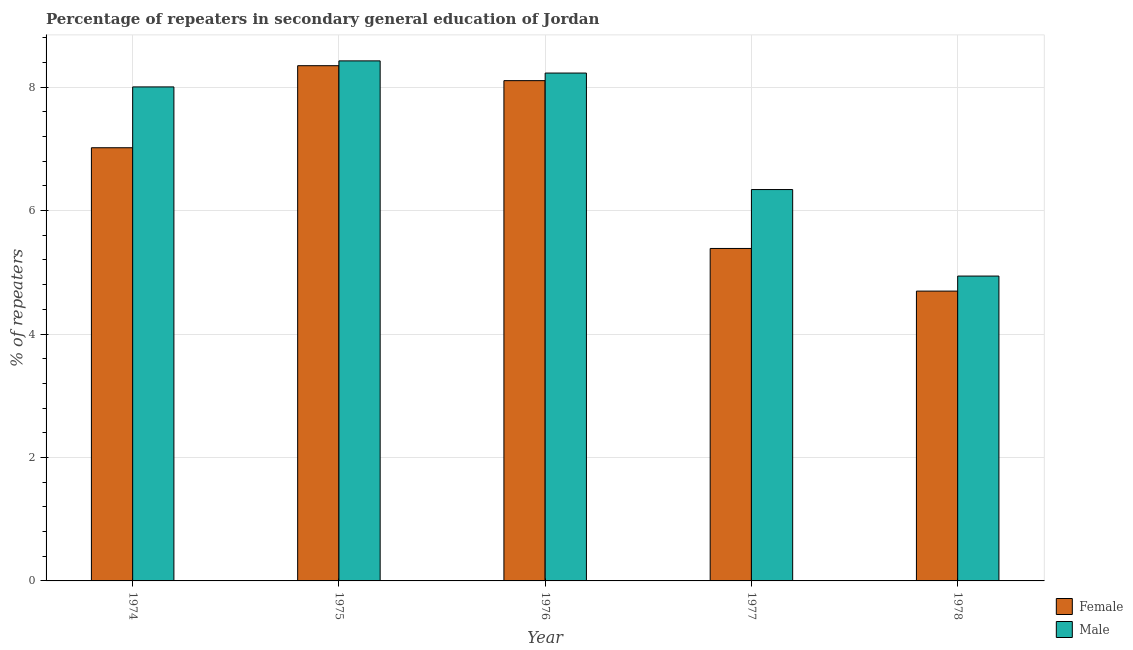How many different coloured bars are there?
Make the answer very short. 2. How many groups of bars are there?
Your answer should be very brief. 5. Are the number of bars per tick equal to the number of legend labels?
Offer a very short reply. Yes. How many bars are there on the 5th tick from the left?
Your answer should be very brief. 2. How many bars are there on the 4th tick from the right?
Give a very brief answer. 2. What is the label of the 1st group of bars from the left?
Your answer should be compact. 1974. In how many cases, is the number of bars for a given year not equal to the number of legend labels?
Your answer should be compact. 0. What is the percentage of female repeaters in 1978?
Your answer should be compact. 4.7. Across all years, what is the maximum percentage of male repeaters?
Your answer should be very brief. 8.43. Across all years, what is the minimum percentage of female repeaters?
Your answer should be very brief. 4.7. In which year was the percentage of female repeaters maximum?
Your answer should be very brief. 1975. In which year was the percentage of female repeaters minimum?
Make the answer very short. 1978. What is the total percentage of female repeaters in the graph?
Offer a terse response. 33.56. What is the difference between the percentage of female repeaters in 1975 and that in 1977?
Your answer should be very brief. 2.96. What is the difference between the percentage of male repeaters in 1976 and the percentage of female repeaters in 1977?
Offer a terse response. 1.89. What is the average percentage of female repeaters per year?
Make the answer very short. 6.71. In the year 1977, what is the difference between the percentage of female repeaters and percentage of male repeaters?
Your response must be concise. 0. What is the ratio of the percentage of female repeaters in 1975 to that in 1976?
Keep it short and to the point. 1.03. Is the percentage of male repeaters in 1974 less than that in 1976?
Keep it short and to the point. Yes. What is the difference between the highest and the second highest percentage of male repeaters?
Your response must be concise. 0.2. What is the difference between the highest and the lowest percentage of female repeaters?
Make the answer very short. 3.65. How many bars are there?
Ensure brevity in your answer.  10. Are all the bars in the graph horizontal?
Ensure brevity in your answer.  No. What is the difference between two consecutive major ticks on the Y-axis?
Your response must be concise. 2. Are the values on the major ticks of Y-axis written in scientific E-notation?
Offer a very short reply. No. Does the graph contain grids?
Provide a succinct answer. Yes. Where does the legend appear in the graph?
Your answer should be very brief. Bottom right. How are the legend labels stacked?
Offer a very short reply. Vertical. What is the title of the graph?
Your answer should be very brief. Percentage of repeaters in secondary general education of Jordan. Does "Arms exports" appear as one of the legend labels in the graph?
Your answer should be compact. No. What is the label or title of the Y-axis?
Make the answer very short. % of repeaters. What is the % of repeaters of Female in 1974?
Offer a terse response. 7.02. What is the % of repeaters of Male in 1974?
Give a very brief answer. 8. What is the % of repeaters of Female in 1975?
Your answer should be very brief. 8.35. What is the % of repeaters of Male in 1975?
Give a very brief answer. 8.43. What is the % of repeaters in Female in 1976?
Your answer should be compact. 8.11. What is the % of repeaters in Male in 1976?
Your answer should be very brief. 8.23. What is the % of repeaters in Female in 1977?
Provide a short and direct response. 5.39. What is the % of repeaters in Male in 1977?
Provide a succinct answer. 6.34. What is the % of repeaters in Female in 1978?
Ensure brevity in your answer.  4.7. What is the % of repeaters in Male in 1978?
Your answer should be very brief. 4.94. Across all years, what is the maximum % of repeaters in Female?
Ensure brevity in your answer.  8.35. Across all years, what is the maximum % of repeaters in Male?
Your answer should be very brief. 8.43. Across all years, what is the minimum % of repeaters in Female?
Your response must be concise. 4.7. Across all years, what is the minimum % of repeaters in Male?
Provide a short and direct response. 4.94. What is the total % of repeaters of Female in the graph?
Give a very brief answer. 33.56. What is the total % of repeaters of Male in the graph?
Provide a short and direct response. 35.94. What is the difference between the % of repeaters of Female in 1974 and that in 1975?
Your answer should be compact. -1.33. What is the difference between the % of repeaters of Male in 1974 and that in 1975?
Offer a terse response. -0.42. What is the difference between the % of repeaters of Female in 1974 and that in 1976?
Give a very brief answer. -1.09. What is the difference between the % of repeaters in Male in 1974 and that in 1976?
Give a very brief answer. -0.22. What is the difference between the % of repeaters of Female in 1974 and that in 1977?
Offer a very short reply. 1.63. What is the difference between the % of repeaters in Male in 1974 and that in 1977?
Ensure brevity in your answer.  1.66. What is the difference between the % of repeaters of Female in 1974 and that in 1978?
Make the answer very short. 2.32. What is the difference between the % of repeaters of Male in 1974 and that in 1978?
Offer a terse response. 3.07. What is the difference between the % of repeaters in Female in 1975 and that in 1976?
Your response must be concise. 0.24. What is the difference between the % of repeaters in Male in 1975 and that in 1976?
Your answer should be compact. 0.2. What is the difference between the % of repeaters of Female in 1975 and that in 1977?
Ensure brevity in your answer.  2.96. What is the difference between the % of repeaters in Male in 1975 and that in 1977?
Your answer should be compact. 2.08. What is the difference between the % of repeaters of Female in 1975 and that in 1978?
Keep it short and to the point. 3.65. What is the difference between the % of repeaters in Male in 1975 and that in 1978?
Make the answer very short. 3.49. What is the difference between the % of repeaters in Female in 1976 and that in 1977?
Offer a very short reply. 2.72. What is the difference between the % of repeaters in Male in 1976 and that in 1977?
Keep it short and to the point. 1.89. What is the difference between the % of repeaters of Female in 1976 and that in 1978?
Your answer should be very brief. 3.41. What is the difference between the % of repeaters of Male in 1976 and that in 1978?
Give a very brief answer. 3.29. What is the difference between the % of repeaters of Female in 1977 and that in 1978?
Make the answer very short. 0.69. What is the difference between the % of repeaters of Male in 1977 and that in 1978?
Offer a very short reply. 1.4. What is the difference between the % of repeaters in Female in 1974 and the % of repeaters in Male in 1975?
Offer a very short reply. -1.41. What is the difference between the % of repeaters of Female in 1974 and the % of repeaters of Male in 1976?
Ensure brevity in your answer.  -1.21. What is the difference between the % of repeaters of Female in 1974 and the % of repeaters of Male in 1977?
Offer a very short reply. 0.68. What is the difference between the % of repeaters in Female in 1974 and the % of repeaters in Male in 1978?
Your answer should be very brief. 2.08. What is the difference between the % of repeaters of Female in 1975 and the % of repeaters of Male in 1976?
Give a very brief answer. 0.12. What is the difference between the % of repeaters in Female in 1975 and the % of repeaters in Male in 1977?
Offer a very short reply. 2.01. What is the difference between the % of repeaters in Female in 1975 and the % of repeaters in Male in 1978?
Make the answer very short. 3.41. What is the difference between the % of repeaters of Female in 1976 and the % of repeaters of Male in 1977?
Your response must be concise. 1.76. What is the difference between the % of repeaters of Female in 1976 and the % of repeaters of Male in 1978?
Keep it short and to the point. 3.17. What is the difference between the % of repeaters in Female in 1977 and the % of repeaters in Male in 1978?
Your answer should be very brief. 0.45. What is the average % of repeaters in Female per year?
Give a very brief answer. 6.71. What is the average % of repeaters of Male per year?
Keep it short and to the point. 7.19. In the year 1974, what is the difference between the % of repeaters in Female and % of repeaters in Male?
Keep it short and to the point. -0.99. In the year 1975, what is the difference between the % of repeaters of Female and % of repeaters of Male?
Give a very brief answer. -0.08. In the year 1976, what is the difference between the % of repeaters of Female and % of repeaters of Male?
Provide a short and direct response. -0.12. In the year 1977, what is the difference between the % of repeaters of Female and % of repeaters of Male?
Your response must be concise. -0.95. In the year 1978, what is the difference between the % of repeaters of Female and % of repeaters of Male?
Offer a very short reply. -0.24. What is the ratio of the % of repeaters in Female in 1974 to that in 1975?
Give a very brief answer. 0.84. What is the ratio of the % of repeaters in Male in 1974 to that in 1975?
Your response must be concise. 0.95. What is the ratio of the % of repeaters in Female in 1974 to that in 1976?
Your answer should be compact. 0.87. What is the ratio of the % of repeaters of Male in 1974 to that in 1976?
Your answer should be very brief. 0.97. What is the ratio of the % of repeaters in Female in 1974 to that in 1977?
Provide a short and direct response. 1.3. What is the ratio of the % of repeaters in Male in 1974 to that in 1977?
Offer a terse response. 1.26. What is the ratio of the % of repeaters in Female in 1974 to that in 1978?
Ensure brevity in your answer.  1.49. What is the ratio of the % of repeaters of Male in 1974 to that in 1978?
Keep it short and to the point. 1.62. What is the ratio of the % of repeaters of Female in 1975 to that in 1976?
Offer a very short reply. 1.03. What is the ratio of the % of repeaters in Male in 1975 to that in 1976?
Keep it short and to the point. 1.02. What is the ratio of the % of repeaters in Female in 1975 to that in 1977?
Your response must be concise. 1.55. What is the ratio of the % of repeaters in Male in 1975 to that in 1977?
Your answer should be compact. 1.33. What is the ratio of the % of repeaters of Female in 1975 to that in 1978?
Offer a very short reply. 1.78. What is the ratio of the % of repeaters of Male in 1975 to that in 1978?
Your answer should be very brief. 1.71. What is the ratio of the % of repeaters in Female in 1976 to that in 1977?
Ensure brevity in your answer.  1.5. What is the ratio of the % of repeaters of Male in 1976 to that in 1977?
Ensure brevity in your answer.  1.3. What is the ratio of the % of repeaters in Female in 1976 to that in 1978?
Offer a terse response. 1.73. What is the ratio of the % of repeaters in Male in 1976 to that in 1978?
Give a very brief answer. 1.67. What is the ratio of the % of repeaters in Female in 1977 to that in 1978?
Your answer should be compact. 1.15. What is the ratio of the % of repeaters of Male in 1977 to that in 1978?
Give a very brief answer. 1.28. What is the difference between the highest and the second highest % of repeaters in Female?
Offer a terse response. 0.24. What is the difference between the highest and the second highest % of repeaters in Male?
Offer a very short reply. 0.2. What is the difference between the highest and the lowest % of repeaters in Female?
Keep it short and to the point. 3.65. What is the difference between the highest and the lowest % of repeaters in Male?
Offer a terse response. 3.49. 